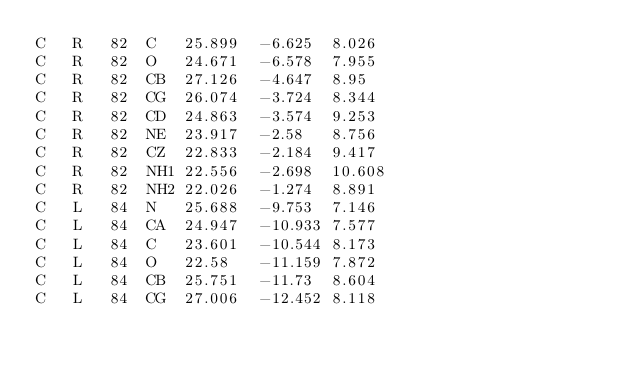<code> <loc_0><loc_0><loc_500><loc_500><_SQL_>C	R	82	C	25.899	-6.625	8.026
C	R	82	O	24.671	-6.578	7.955
C	R	82	CB	27.126	-4.647	8.95
C	R	82	CG	26.074	-3.724	8.344
C	R	82	CD	24.863	-3.574	9.253
C	R	82	NE	23.917	-2.58	8.756
C	R	82	CZ	22.833	-2.184	9.417
C	R	82	NH1	22.556	-2.698	10.608
C	R	82	NH2	22.026	-1.274	8.891
C	L	84	N	25.688	-9.753	7.146
C	L	84	CA	24.947	-10.933	7.577
C	L	84	C	23.601	-10.544	8.173
C	L	84	O	22.58	-11.159	7.872
C	L	84	CB	25.751	-11.73	8.604
C	L	84	CG	27.006	-12.452	8.118</code> 